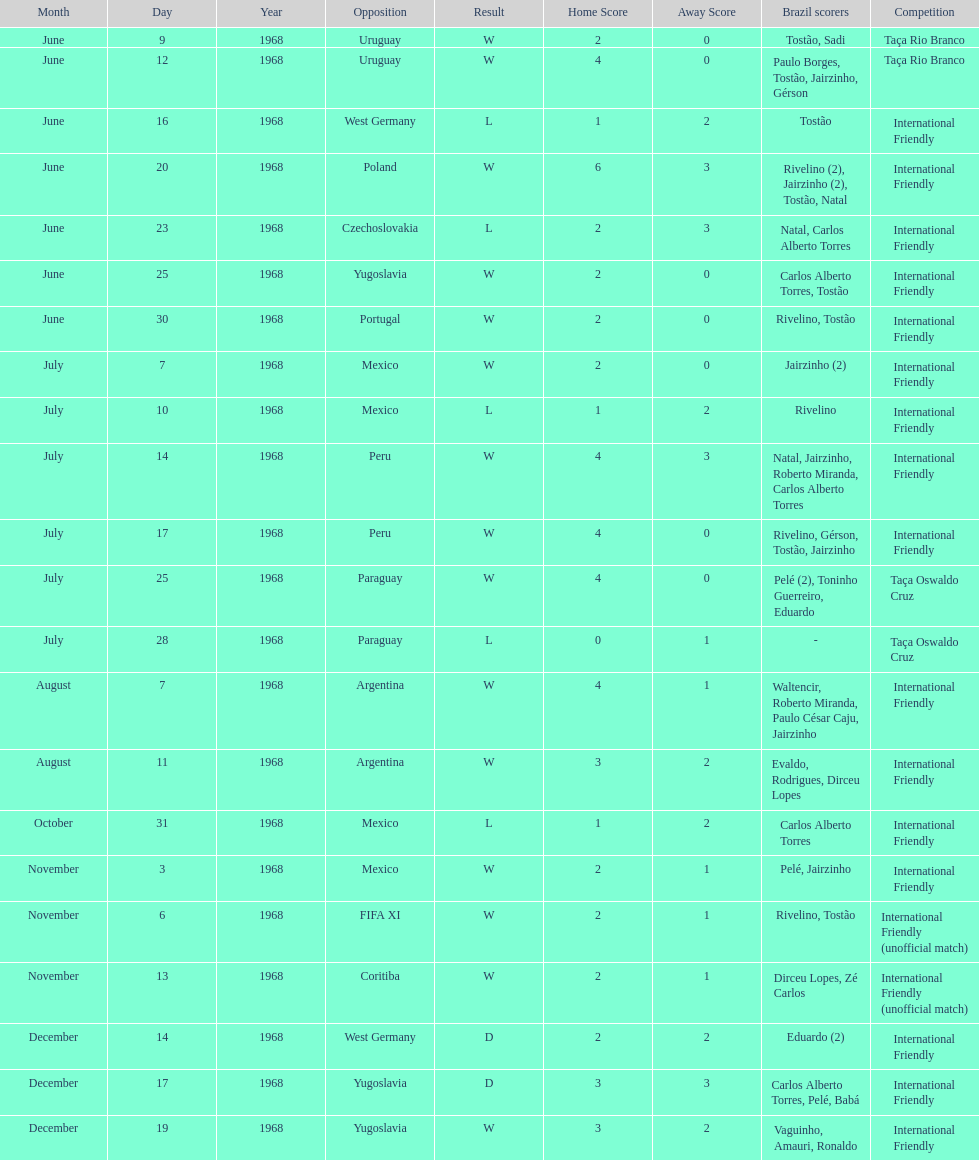What is the top score ever scored by the brazil national team? 6. 